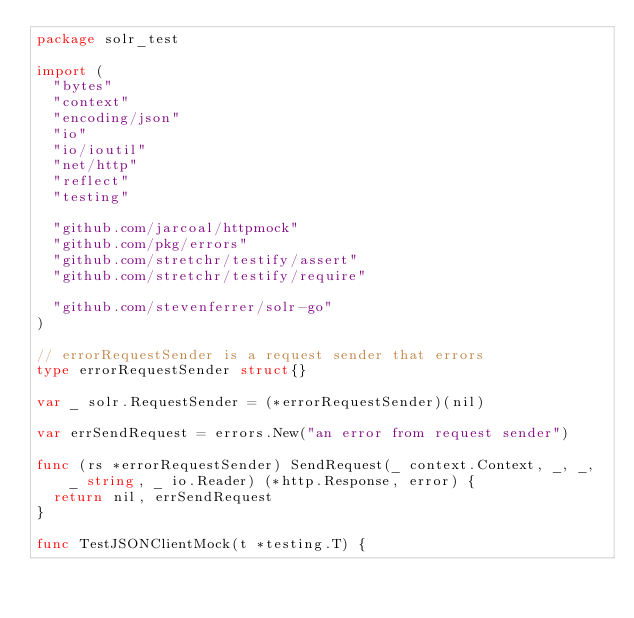Convert code to text. <code><loc_0><loc_0><loc_500><loc_500><_Go_>package solr_test

import (
	"bytes"
	"context"
	"encoding/json"
	"io"
	"io/ioutil"
	"net/http"
	"reflect"
	"testing"

	"github.com/jarcoal/httpmock"
	"github.com/pkg/errors"
	"github.com/stretchr/testify/assert"
	"github.com/stretchr/testify/require"

	"github.com/stevenferrer/solr-go"
)

// errorRequestSender is a request sender that errors
type errorRequestSender struct{}

var _ solr.RequestSender = (*errorRequestSender)(nil)

var errSendRequest = errors.New("an error from request sender")

func (rs *errorRequestSender) SendRequest(_ context.Context, _, _, _ string, _ io.Reader) (*http.Response, error) {
	return nil, errSendRequest
}

func TestJSONClientMock(t *testing.T) {</code> 